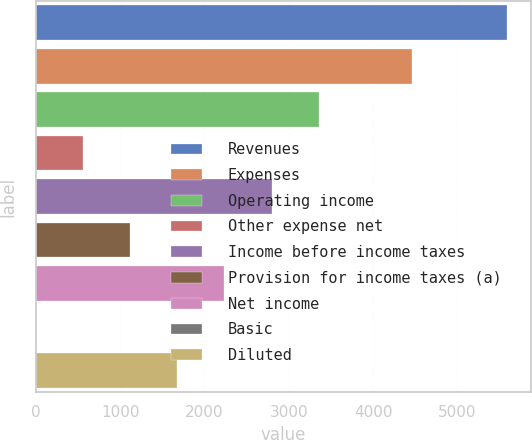Convert chart to OTSL. <chart><loc_0><loc_0><loc_500><loc_500><bar_chart><fcel>Revenues<fcel>Expenses<fcel>Operating income<fcel>Other expense net<fcel>Income before income taxes<fcel>Provision for income taxes (a)<fcel>Net income<fcel>Basic<fcel>Diluted<nl><fcel>5589.9<fcel>4467.8<fcel>3354.69<fcel>560.69<fcel>2795.89<fcel>1119.49<fcel>2237.09<fcel>1.89<fcel>1678.29<nl></chart> 